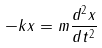<formula> <loc_0><loc_0><loc_500><loc_500>- k x = m \frac { d ^ { 2 } x } { d t ^ { 2 } }</formula> 